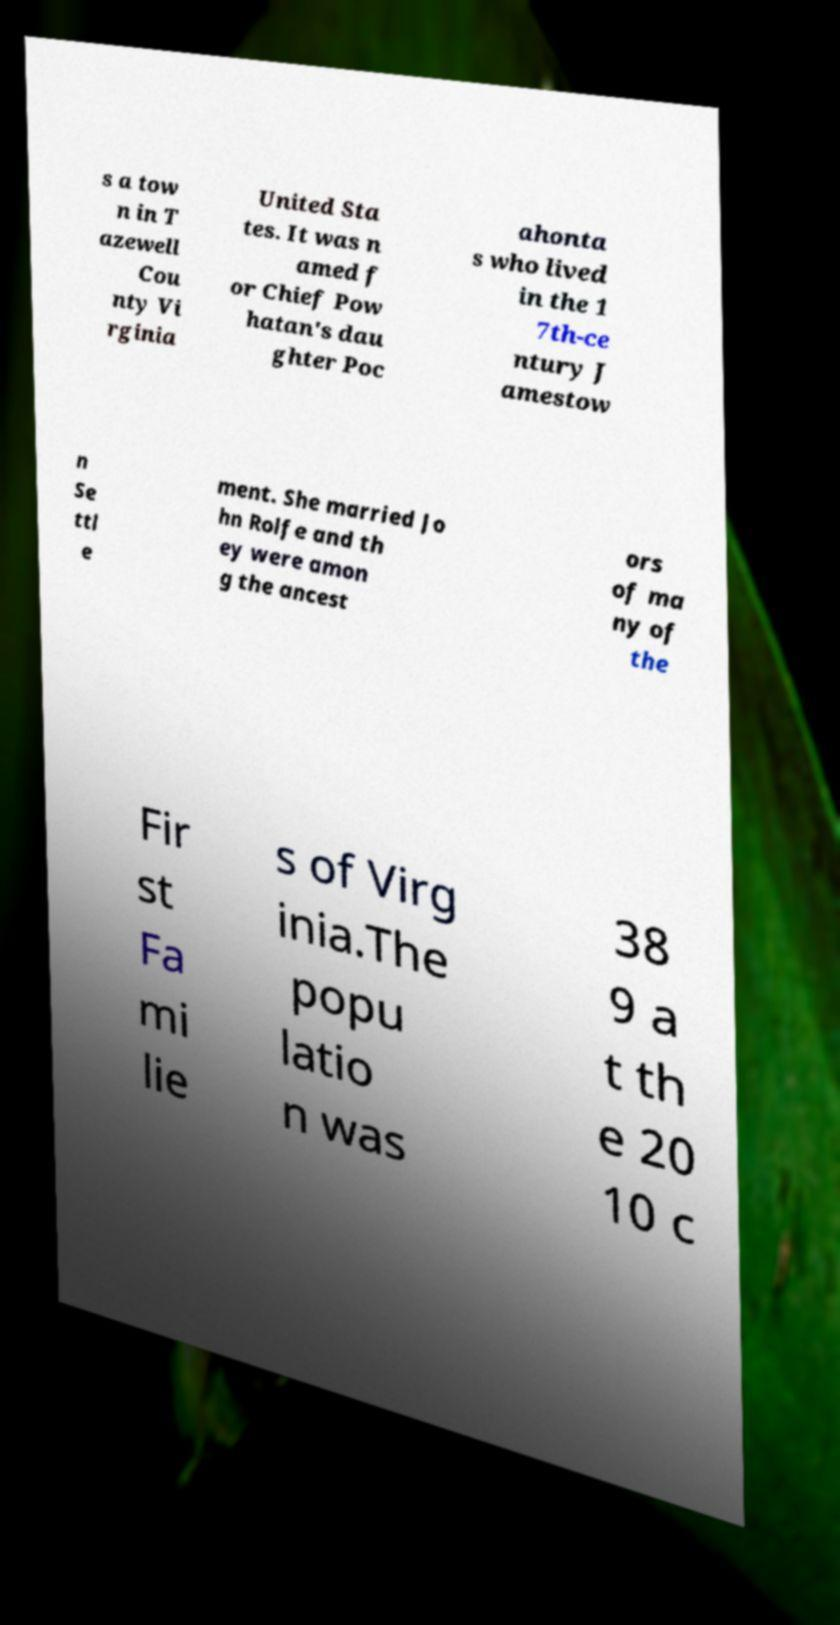Please identify and transcribe the text found in this image. s a tow n in T azewell Cou nty Vi rginia United Sta tes. It was n amed f or Chief Pow hatan's dau ghter Poc ahonta s who lived in the 1 7th-ce ntury J amestow n Se ttl e ment. She married Jo hn Rolfe and th ey were amon g the ancest ors of ma ny of the Fir st Fa mi lie s of Virg inia.The popu latio n was 38 9 a t th e 20 10 c 